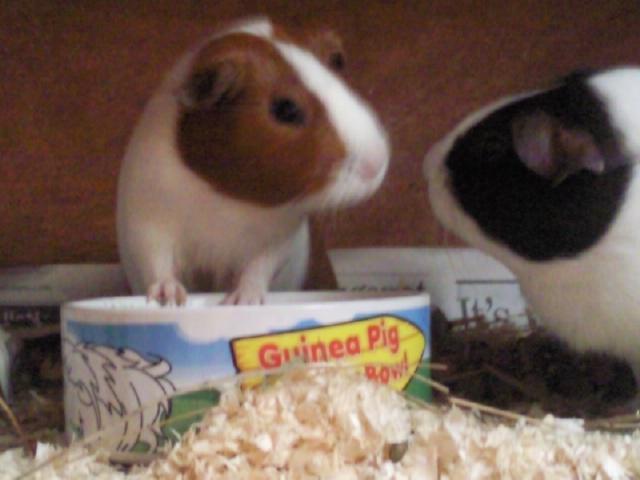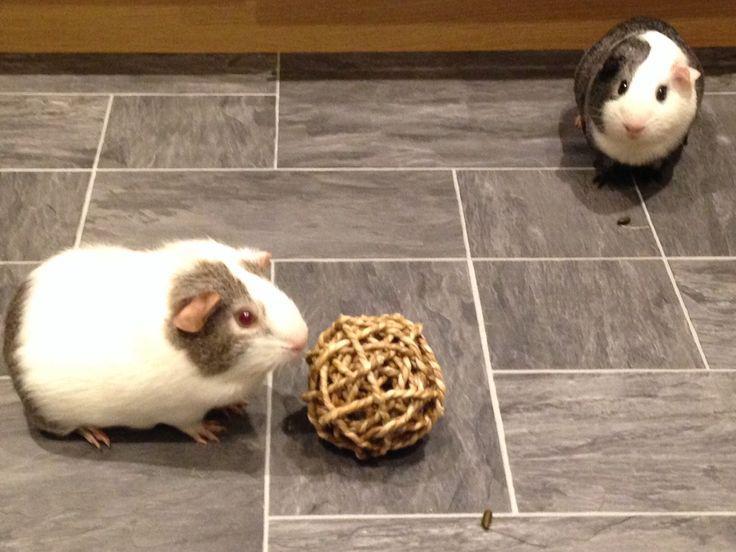The first image is the image on the left, the second image is the image on the right. Assess this claim about the two images: "The animal in one of the images is in a wire cage.". Correct or not? Answer yes or no. No. 